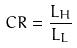Convert formula to latex. <formula><loc_0><loc_0><loc_500><loc_500>C R = \frac { L _ { H } } { L _ { L } }</formula> 